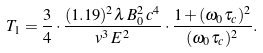<formula> <loc_0><loc_0><loc_500><loc_500>T _ { 1 } = \frac { 3 } { 4 } \cdot \frac { ( 1 . 1 9 ) ^ { 2 } \lambda \, B _ { 0 } ^ { 2 } \, c ^ { 4 } } { v ^ { 3 } \, E ^ { 2 } } \cdot \frac { 1 + ( \omega _ { 0 } \tau _ { c } ) ^ { 2 } } { ( \omega _ { 0 } \tau _ { c } ) ^ { 2 } } .</formula> 